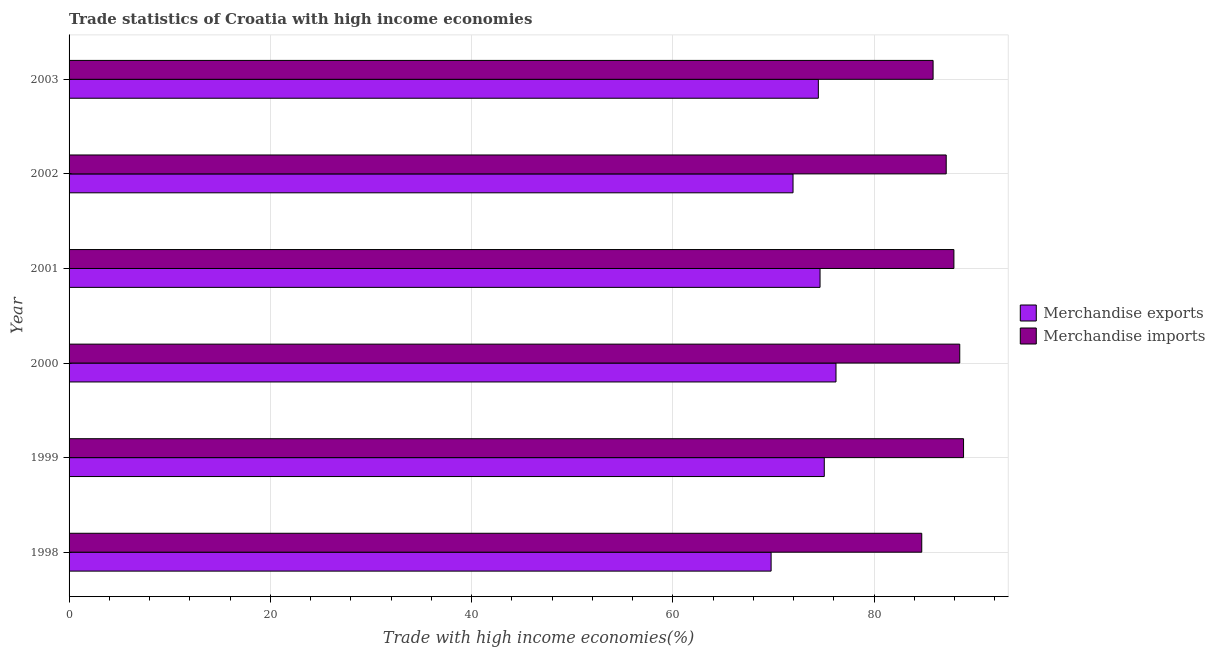How many different coloured bars are there?
Ensure brevity in your answer.  2. What is the label of the 6th group of bars from the top?
Offer a very short reply. 1998. What is the merchandise exports in 1999?
Offer a terse response. 75.04. Across all years, what is the maximum merchandise exports?
Keep it short and to the point. 76.21. Across all years, what is the minimum merchandise imports?
Your response must be concise. 84.73. In which year was the merchandise exports minimum?
Ensure brevity in your answer.  1998. What is the total merchandise exports in the graph?
Offer a terse response. 442.02. What is the difference between the merchandise imports in 2002 and that in 2003?
Provide a short and direct response. 1.3. What is the difference between the merchandise exports in 1998 and the merchandise imports in 2000?
Your answer should be compact. -18.74. What is the average merchandise imports per year?
Make the answer very short. 87.17. In the year 2000, what is the difference between the merchandise exports and merchandise imports?
Provide a succinct answer. -12.3. What is the difference between the highest and the second highest merchandise exports?
Your answer should be very brief. 1.17. What is the difference between the highest and the lowest merchandise imports?
Keep it short and to the point. 4.15. What does the 1st bar from the bottom in 2000 represents?
Your response must be concise. Merchandise exports. Are all the bars in the graph horizontal?
Make the answer very short. Yes. What is the difference between two consecutive major ticks on the X-axis?
Provide a short and direct response. 20. Are the values on the major ticks of X-axis written in scientific E-notation?
Offer a very short reply. No. How are the legend labels stacked?
Offer a terse response. Vertical. What is the title of the graph?
Your answer should be compact. Trade statistics of Croatia with high income economies. Does "Unregistered firms" appear as one of the legend labels in the graph?
Your answer should be very brief. No. What is the label or title of the X-axis?
Give a very brief answer. Trade with high income economies(%). What is the Trade with high income economies(%) in Merchandise exports in 1998?
Ensure brevity in your answer.  69.76. What is the Trade with high income economies(%) of Merchandise imports in 1998?
Your answer should be very brief. 84.73. What is the Trade with high income economies(%) in Merchandise exports in 1999?
Your answer should be very brief. 75.04. What is the Trade with high income economies(%) of Merchandise imports in 1999?
Provide a succinct answer. 88.88. What is the Trade with high income economies(%) in Merchandise exports in 2000?
Keep it short and to the point. 76.21. What is the Trade with high income economies(%) of Merchandise imports in 2000?
Ensure brevity in your answer.  88.5. What is the Trade with high income economies(%) in Merchandise exports in 2001?
Offer a very short reply. 74.62. What is the Trade with high income economies(%) in Merchandise imports in 2001?
Provide a succinct answer. 87.92. What is the Trade with high income economies(%) in Merchandise exports in 2002?
Keep it short and to the point. 71.94. What is the Trade with high income economies(%) in Merchandise imports in 2002?
Offer a terse response. 87.16. What is the Trade with high income economies(%) in Merchandise exports in 2003?
Ensure brevity in your answer.  74.45. What is the Trade with high income economies(%) in Merchandise imports in 2003?
Your answer should be compact. 85.85. Across all years, what is the maximum Trade with high income economies(%) in Merchandise exports?
Ensure brevity in your answer.  76.21. Across all years, what is the maximum Trade with high income economies(%) of Merchandise imports?
Offer a very short reply. 88.88. Across all years, what is the minimum Trade with high income economies(%) of Merchandise exports?
Provide a succinct answer. 69.76. Across all years, what is the minimum Trade with high income economies(%) in Merchandise imports?
Your answer should be very brief. 84.73. What is the total Trade with high income economies(%) of Merchandise exports in the graph?
Provide a short and direct response. 442.02. What is the total Trade with high income economies(%) of Merchandise imports in the graph?
Offer a very short reply. 523.05. What is the difference between the Trade with high income economies(%) of Merchandise exports in 1998 and that in 1999?
Offer a terse response. -5.28. What is the difference between the Trade with high income economies(%) in Merchandise imports in 1998 and that in 1999?
Offer a terse response. -4.15. What is the difference between the Trade with high income economies(%) in Merchandise exports in 1998 and that in 2000?
Your response must be concise. -6.45. What is the difference between the Trade with high income economies(%) of Merchandise imports in 1998 and that in 2000?
Your response must be concise. -3.78. What is the difference between the Trade with high income economies(%) of Merchandise exports in 1998 and that in 2001?
Make the answer very short. -4.86. What is the difference between the Trade with high income economies(%) in Merchandise imports in 1998 and that in 2001?
Make the answer very short. -3.2. What is the difference between the Trade with high income economies(%) in Merchandise exports in 1998 and that in 2002?
Make the answer very short. -2.18. What is the difference between the Trade with high income economies(%) of Merchandise imports in 1998 and that in 2002?
Ensure brevity in your answer.  -2.43. What is the difference between the Trade with high income economies(%) of Merchandise exports in 1998 and that in 2003?
Keep it short and to the point. -4.69. What is the difference between the Trade with high income economies(%) in Merchandise imports in 1998 and that in 2003?
Provide a succinct answer. -1.13. What is the difference between the Trade with high income economies(%) in Merchandise exports in 1999 and that in 2000?
Provide a succinct answer. -1.16. What is the difference between the Trade with high income economies(%) of Merchandise imports in 1999 and that in 2000?
Offer a very short reply. 0.38. What is the difference between the Trade with high income economies(%) of Merchandise exports in 1999 and that in 2001?
Provide a succinct answer. 0.42. What is the difference between the Trade with high income economies(%) in Merchandise imports in 1999 and that in 2001?
Your response must be concise. 0.96. What is the difference between the Trade with high income economies(%) in Merchandise exports in 1999 and that in 2002?
Keep it short and to the point. 3.1. What is the difference between the Trade with high income economies(%) of Merchandise imports in 1999 and that in 2002?
Your response must be concise. 1.72. What is the difference between the Trade with high income economies(%) of Merchandise exports in 1999 and that in 2003?
Your answer should be very brief. 0.59. What is the difference between the Trade with high income economies(%) of Merchandise imports in 1999 and that in 2003?
Give a very brief answer. 3.03. What is the difference between the Trade with high income economies(%) of Merchandise exports in 2000 and that in 2001?
Ensure brevity in your answer.  1.58. What is the difference between the Trade with high income economies(%) of Merchandise imports in 2000 and that in 2001?
Your answer should be very brief. 0.58. What is the difference between the Trade with high income economies(%) in Merchandise exports in 2000 and that in 2002?
Ensure brevity in your answer.  4.27. What is the difference between the Trade with high income economies(%) in Merchandise imports in 2000 and that in 2002?
Ensure brevity in your answer.  1.34. What is the difference between the Trade with high income economies(%) in Merchandise exports in 2000 and that in 2003?
Your response must be concise. 1.75. What is the difference between the Trade with high income economies(%) in Merchandise imports in 2000 and that in 2003?
Keep it short and to the point. 2.65. What is the difference between the Trade with high income economies(%) in Merchandise exports in 2001 and that in 2002?
Your answer should be very brief. 2.68. What is the difference between the Trade with high income economies(%) in Merchandise imports in 2001 and that in 2002?
Your answer should be very brief. 0.76. What is the difference between the Trade with high income economies(%) in Merchandise exports in 2001 and that in 2003?
Keep it short and to the point. 0.17. What is the difference between the Trade with high income economies(%) of Merchandise imports in 2001 and that in 2003?
Make the answer very short. 2.07. What is the difference between the Trade with high income economies(%) of Merchandise exports in 2002 and that in 2003?
Ensure brevity in your answer.  -2.51. What is the difference between the Trade with high income economies(%) in Merchandise imports in 2002 and that in 2003?
Give a very brief answer. 1.3. What is the difference between the Trade with high income economies(%) of Merchandise exports in 1998 and the Trade with high income economies(%) of Merchandise imports in 1999?
Your answer should be very brief. -19.12. What is the difference between the Trade with high income economies(%) of Merchandise exports in 1998 and the Trade with high income economies(%) of Merchandise imports in 2000?
Give a very brief answer. -18.74. What is the difference between the Trade with high income economies(%) in Merchandise exports in 1998 and the Trade with high income economies(%) in Merchandise imports in 2001?
Offer a very short reply. -18.16. What is the difference between the Trade with high income economies(%) of Merchandise exports in 1998 and the Trade with high income economies(%) of Merchandise imports in 2002?
Provide a short and direct response. -17.4. What is the difference between the Trade with high income economies(%) of Merchandise exports in 1998 and the Trade with high income economies(%) of Merchandise imports in 2003?
Offer a terse response. -16.09. What is the difference between the Trade with high income economies(%) of Merchandise exports in 1999 and the Trade with high income economies(%) of Merchandise imports in 2000?
Keep it short and to the point. -13.46. What is the difference between the Trade with high income economies(%) in Merchandise exports in 1999 and the Trade with high income economies(%) in Merchandise imports in 2001?
Offer a terse response. -12.88. What is the difference between the Trade with high income economies(%) in Merchandise exports in 1999 and the Trade with high income economies(%) in Merchandise imports in 2002?
Offer a terse response. -12.12. What is the difference between the Trade with high income economies(%) in Merchandise exports in 1999 and the Trade with high income economies(%) in Merchandise imports in 2003?
Your response must be concise. -10.81. What is the difference between the Trade with high income economies(%) in Merchandise exports in 2000 and the Trade with high income economies(%) in Merchandise imports in 2001?
Offer a very short reply. -11.72. What is the difference between the Trade with high income economies(%) of Merchandise exports in 2000 and the Trade with high income economies(%) of Merchandise imports in 2002?
Your answer should be compact. -10.95. What is the difference between the Trade with high income economies(%) of Merchandise exports in 2000 and the Trade with high income economies(%) of Merchandise imports in 2003?
Offer a terse response. -9.65. What is the difference between the Trade with high income economies(%) of Merchandise exports in 2001 and the Trade with high income economies(%) of Merchandise imports in 2002?
Your response must be concise. -12.54. What is the difference between the Trade with high income economies(%) of Merchandise exports in 2001 and the Trade with high income economies(%) of Merchandise imports in 2003?
Provide a succinct answer. -11.23. What is the difference between the Trade with high income economies(%) of Merchandise exports in 2002 and the Trade with high income economies(%) of Merchandise imports in 2003?
Offer a very short reply. -13.92. What is the average Trade with high income economies(%) of Merchandise exports per year?
Provide a succinct answer. 73.67. What is the average Trade with high income economies(%) in Merchandise imports per year?
Ensure brevity in your answer.  87.18. In the year 1998, what is the difference between the Trade with high income economies(%) of Merchandise exports and Trade with high income economies(%) of Merchandise imports?
Provide a short and direct response. -14.97. In the year 1999, what is the difference between the Trade with high income economies(%) of Merchandise exports and Trade with high income economies(%) of Merchandise imports?
Provide a short and direct response. -13.84. In the year 2000, what is the difference between the Trade with high income economies(%) in Merchandise exports and Trade with high income economies(%) in Merchandise imports?
Your response must be concise. -12.3. In the year 2001, what is the difference between the Trade with high income economies(%) in Merchandise exports and Trade with high income economies(%) in Merchandise imports?
Offer a very short reply. -13.3. In the year 2002, what is the difference between the Trade with high income economies(%) of Merchandise exports and Trade with high income economies(%) of Merchandise imports?
Your answer should be compact. -15.22. In the year 2003, what is the difference between the Trade with high income economies(%) of Merchandise exports and Trade with high income economies(%) of Merchandise imports?
Provide a succinct answer. -11.4. What is the ratio of the Trade with high income economies(%) in Merchandise exports in 1998 to that in 1999?
Your response must be concise. 0.93. What is the ratio of the Trade with high income economies(%) of Merchandise imports in 1998 to that in 1999?
Ensure brevity in your answer.  0.95. What is the ratio of the Trade with high income economies(%) of Merchandise exports in 1998 to that in 2000?
Ensure brevity in your answer.  0.92. What is the ratio of the Trade with high income economies(%) of Merchandise imports in 1998 to that in 2000?
Give a very brief answer. 0.96. What is the ratio of the Trade with high income economies(%) in Merchandise exports in 1998 to that in 2001?
Your answer should be compact. 0.93. What is the ratio of the Trade with high income economies(%) of Merchandise imports in 1998 to that in 2001?
Provide a short and direct response. 0.96. What is the ratio of the Trade with high income economies(%) of Merchandise exports in 1998 to that in 2002?
Make the answer very short. 0.97. What is the ratio of the Trade with high income economies(%) of Merchandise imports in 1998 to that in 2002?
Give a very brief answer. 0.97. What is the ratio of the Trade with high income economies(%) of Merchandise exports in 1998 to that in 2003?
Provide a short and direct response. 0.94. What is the ratio of the Trade with high income economies(%) of Merchandise imports in 1998 to that in 2003?
Give a very brief answer. 0.99. What is the ratio of the Trade with high income economies(%) of Merchandise exports in 1999 to that in 2000?
Ensure brevity in your answer.  0.98. What is the ratio of the Trade with high income economies(%) in Merchandise exports in 1999 to that in 2001?
Your answer should be very brief. 1.01. What is the ratio of the Trade with high income economies(%) of Merchandise imports in 1999 to that in 2001?
Provide a short and direct response. 1.01. What is the ratio of the Trade with high income economies(%) of Merchandise exports in 1999 to that in 2002?
Your response must be concise. 1.04. What is the ratio of the Trade with high income economies(%) of Merchandise imports in 1999 to that in 2002?
Your answer should be very brief. 1.02. What is the ratio of the Trade with high income economies(%) in Merchandise exports in 1999 to that in 2003?
Give a very brief answer. 1.01. What is the ratio of the Trade with high income economies(%) of Merchandise imports in 1999 to that in 2003?
Make the answer very short. 1.04. What is the ratio of the Trade with high income economies(%) of Merchandise exports in 2000 to that in 2001?
Offer a very short reply. 1.02. What is the ratio of the Trade with high income economies(%) in Merchandise imports in 2000 to that in 2001?
Your answer should be very brief. 1.01. What is the ratio of the Trade with high income economies(%) of Merchandise exports in 2000 to that in 2002?
Your answer should be compact. 1.06. What is the ratio of the Trade with high income economies(%) in Merchandise imports in 2000 to that in 2002?
Ensure brevity in your answer.  1.02. What is the ratio of the Trade with high income economies(%) in Merchandise exports in 2000 to that in 2003?
Your answer should be compact. 1.02. What is the ratio of the Trade with high income economies(%) of Merchandise imports in 2000 to that in 2003?
Your answer should be very brief. 1.03. What is the ratio of the Trade with high income economies(%) in Merchandise exports in 2001 to that in 2002?
Provide a succinct answer. 1.04. What is the ratio of the Trade with high income economies(%) of Merchandise imports in 2001 to that in 2002?
Your response must be concise. 1.01. What is the ratio of the Trade with high income economies(%) of Merchandise exports in 2001 to that in 2003?
Provide a short and direct response. 1. What is the ratio of the Trade with high income economies(%) in Merchandise imports in 2001 to that in 2003?
Your answer should be compact. 1.02. What is the ratio of the Trade with high income economies(%) of Merchandise exports in 2002 to that in 2003?
Provide a succinct answer. 0.97. What is the ratio of the Trade with high income economies(%) in Merchandise imports in 2002 to that in 2003?
Your response must be concise. 1.02. What is the difference between the highest and the second highest Trade with high income economies(%) of Merchandise exports?
Provide a short and direct response. 1.16. What is the difference between the highest and the second highest Trade with high income economies(%) of Merchandise imports?
Your response must be concise. 0.38. What is the difference between the highest and the lowest Trade with high income economies(%) of Merchandise exports?
Your response must be concise. 6.45. What is the difference between the highest and the lowest Trade with high income economies(%) in Merchandise imports?
Give a very brief answer. 4.15. 